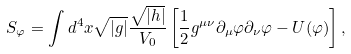<formula> <loc_0><loc_0><loc_500><loc_500>S _ { \varphi } = \int d ^ { 4 } x \sqrt { | g | } \frac { \sqrt { | h | } } { V _ { 0 } } \left [ \frac { 1 } { 2 } g ^ { \mu \nu } \partial _ { \mu } \varphi \partial _ { \nu } \varphi - U ( \varphi ) \right ] ,</formula> 